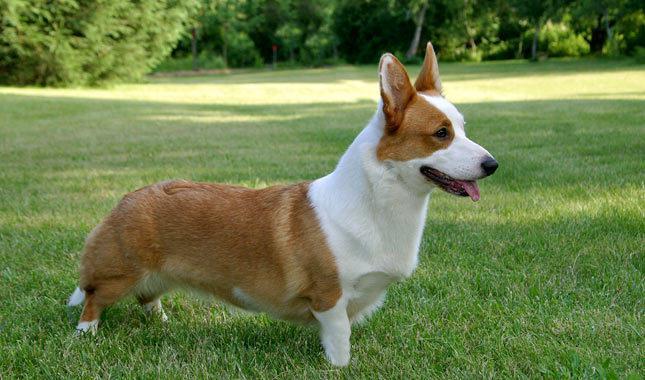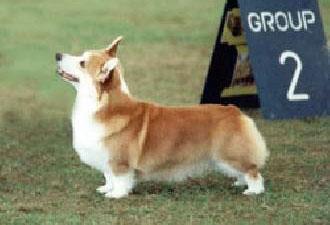The first image is the image on the left, the second image is the image on the right. Considering the images on both sides, is "A dog is facing to the left with his head raised up in a picture." valid? Answer yes or no. Yes. The first image is the image on the left, the second image is the image on the right. Considering the images on both sides, is "All short-legged dogs are standing alert on some grass." valid? Answer yes or no. Yes. 